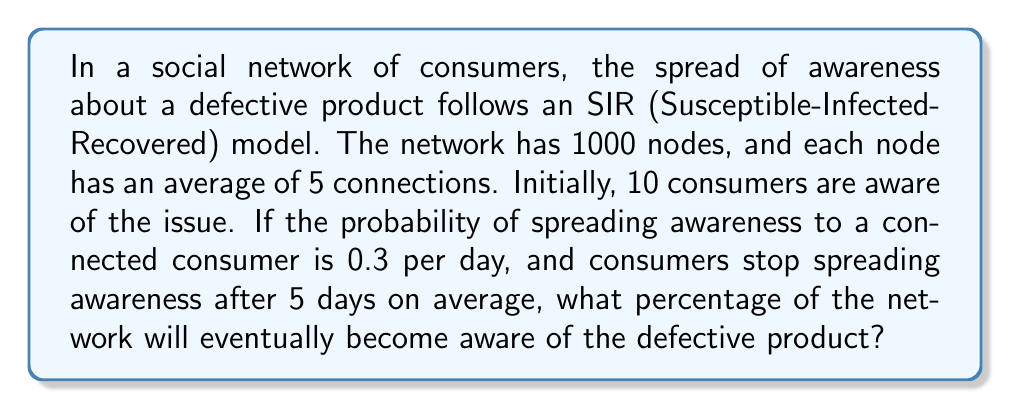What is the answer to this math problem? To solve this problem, we'll use the concept of the basic reproduction number $R_0$ in epidemic models applied to information spreading in networks.

1) First, we need to calculate $R_0$. In a network model, $R_0$ is given by:

   $$R_0 = \frac{\beta \langle k \rangle}{\gamma}$$

   where:
   - $\beta$ is the transmission rate (0.3 per day in this case)
   - $\langle k \rangle$ is the average number of connections (5 in this case)
   - $\gamma$ is the recovery rate (1/5 = 0.2 per day, as consumers stop spreading after 5 days on average)

2) Let's calculate $R_0$:

   $$R_0 = \frac{0.3 \times 5}{0.2} = 7.5$$

3) In SIR models, if $R_0 > 1$, the spreading will reach a significant portion of the population. The final size of the epidemic (or in this case, the proportion of aware consumers) can be estimated using the equation:

   $$R_0 = -\frac{\ln(1-r)}{r}$$

   where $r$ is the proportion of the population that eventually becomes aware.

4) We need to solve this equation numerically. Using numerical methods or a calculator, we find:

   $$r \approx 0.9999$$

5) This means that approximately 99.99% of the network will eventually become aware of the defective product.

6) To convert to a percentage, we multiply by 100:

   $$0.9999 \times 100 \approx 99.99\%$$
Answer: 99.99% 